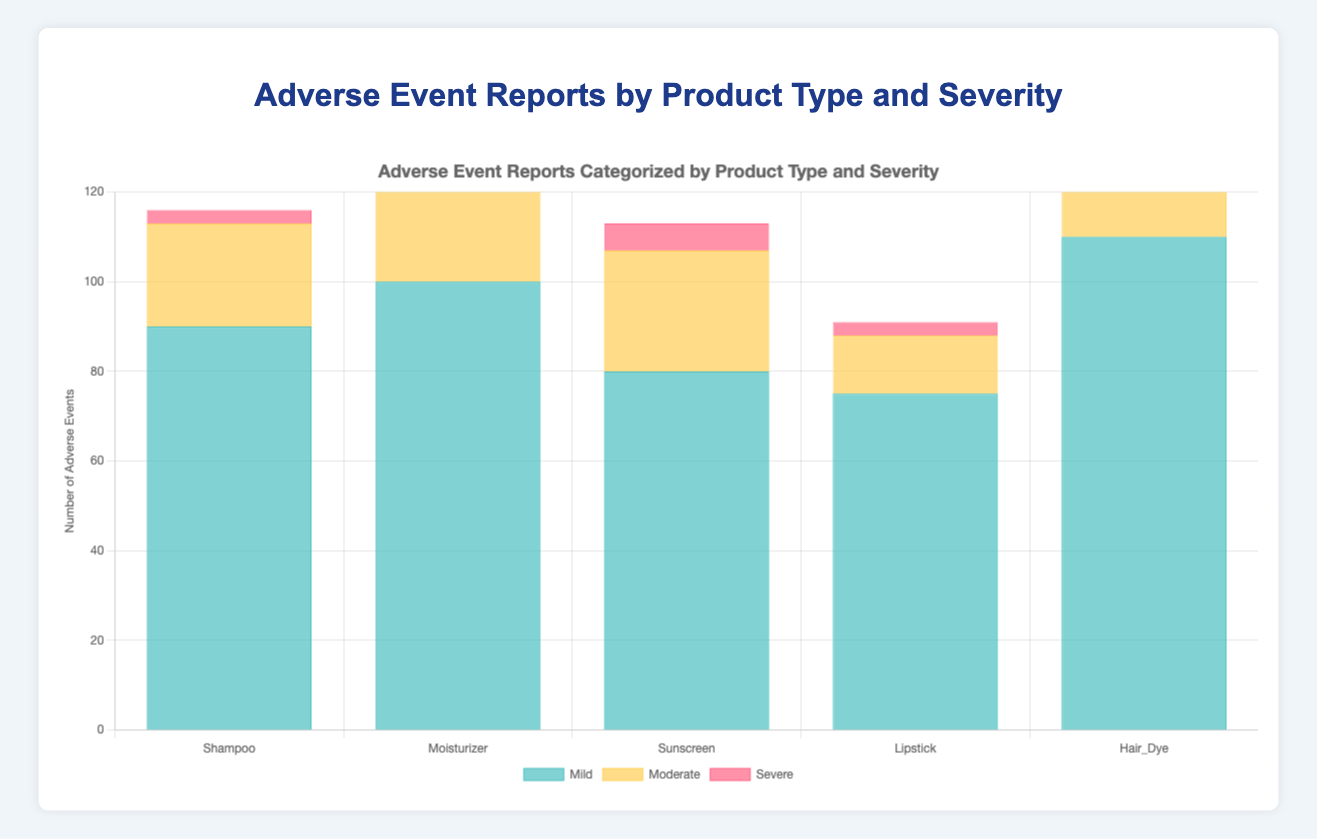Which product type has the highest number of mild adverse events? To find the product type with the highest number of mild adverse events, look at the height of the bars labeled "Mild." The product with the tallest bar is Hair Dye, with a total of 110 mild events.
Answer: Hair Dye Which product type shows the least severe events reported? To determine the product with the least severe events, compare the height of the "Severe" bars. Lipstick has the shortest bar for severe events with just 3 reports.
Answer: Lipstick What is the total number of adverse events reported for Shampoo? Add the numbers for mild (45 + 30 + 15 = 90), moderate (10 + 5 + 8 = 23), and severe (2 + 1 = 3) categories for Shampoo. The total number of adverse events is 90 + 23 + 3 = 116.
Answer: 116 How many more moderate adverse events does Hair Dye have compared to Sunscreen? For Hair Dye, the moderate events total is 20 + 10 + 15 = 45. For Sunscreen, it is 12 + 8 + 7 = 27. The difference is 45 - 27 = 18.
Answer: 18 Which product type has the most balanced distribution of adverse events across severity levels? To find the most balanced distribution, look at the bars' height for each severity category. Shampoo shows a more balanced distribution across Mild (90), Moderate (23), and Severe (3) categories compared to other products.
Answer: Shampoo Compare the number of mild adverse events between Sunscreen and Moisturizer. The Mild category total for Sunscreen is 35 + 25 + 20 = 80, and for Moisturizer, it is 50 + 20 + 30 = 100. Moisturizer has more mild adverse events by 100 - 80 = 20.
Answer: Moisturizer What specific adverse event is most frequent for Hair Dye? By examining the breakdown in the data, Skin Irritation in the mild category has 55 reports, which is the highest for Hair Dye.
Answer: Skin Irritation Which product type has the highest combined number of moderate and severe events? Add the total numbers for moderate and severe events for each product type. The combined total for Hair Dye (45 + 8), Shampoo (23 + 3), Moisturizer (30 + 4), Sunscreen (27 + 6), and Lipstick (13 + 3). Hair Dye has the highest combined total of 53.
Answer: Hair Dye 